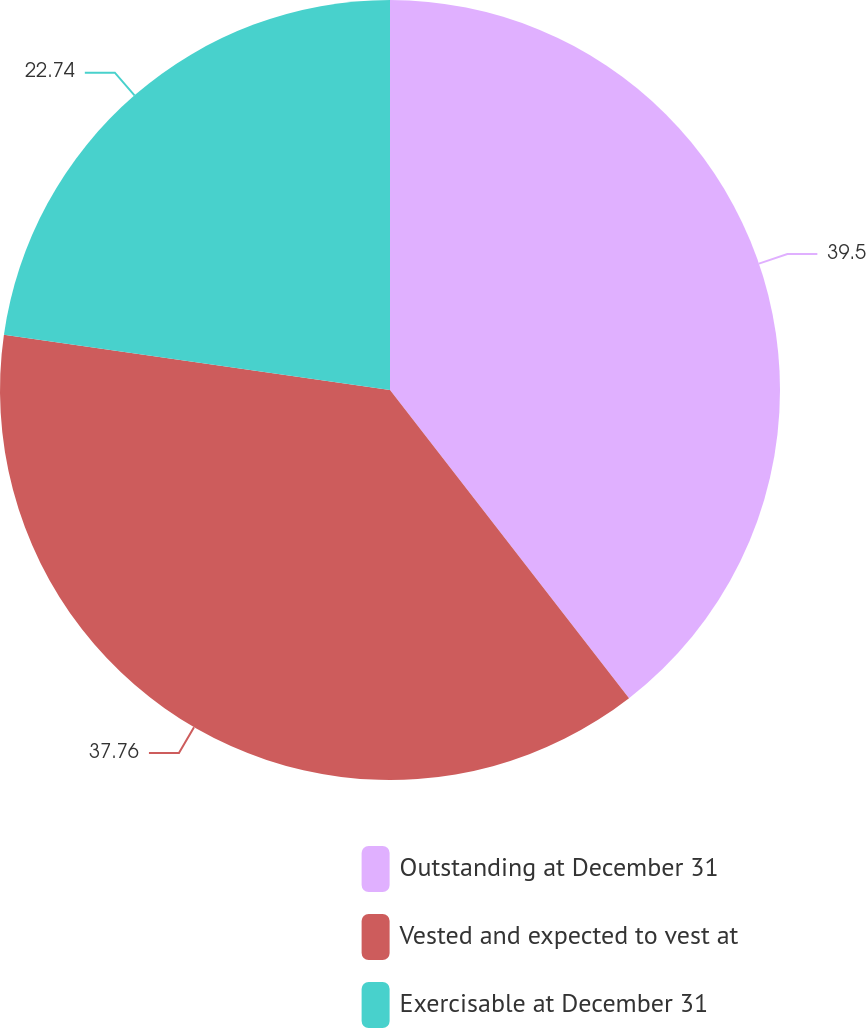Convert chart to OTSL. <chart><loc_0><loc_0><loc_500><loc_500><pie_chart><fcel>Outstanding at December 31<fcel>Vested and expected to vest at<fcel>Exercisable at December 31<nl><fcel>39.5%<fcel>37.76%<fcel>22.74%<nl></chart> 